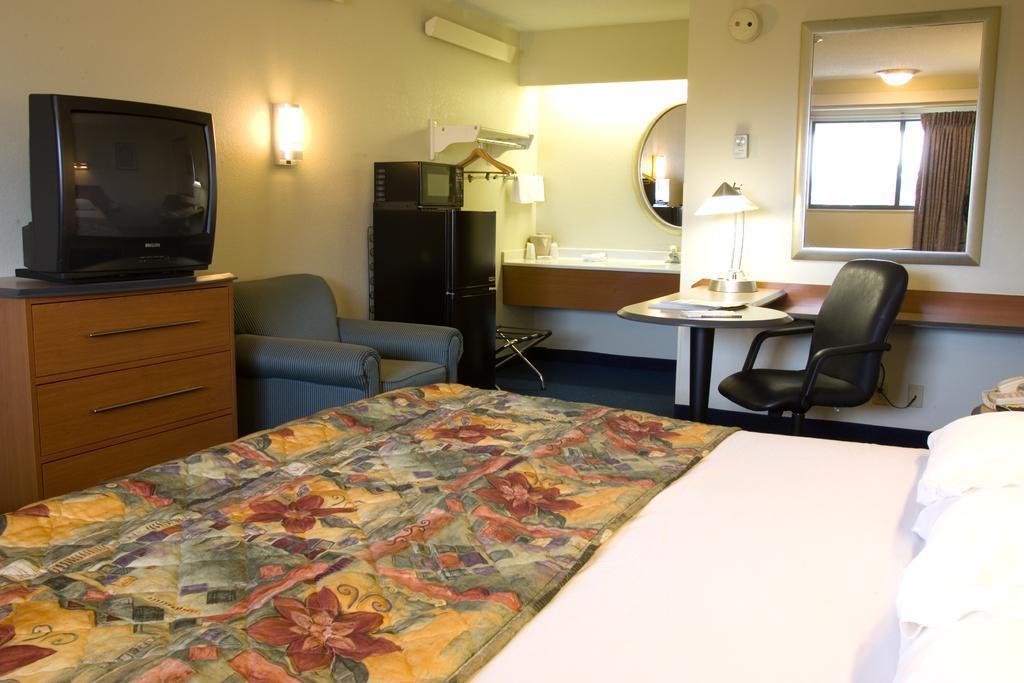In one or two sentences, can you explain what this image depicts? In front of the image there is a bed. On top of it there is a blanket and there are pillows. Beside the bed there is a landline phone on the table. There is a chair and a couch. There is a TV on the table. There is a fridge. On top of it there is a microwave. Beside the fridge there is some object. There are mirrors, AC, light and some other objects on the wall. Through the mirror, we can see glass window, curtain and a light. There are tables. On top of it there is a lamp, papers and a pen. In the background of the image there is a sink and there are some objects on the platform. 